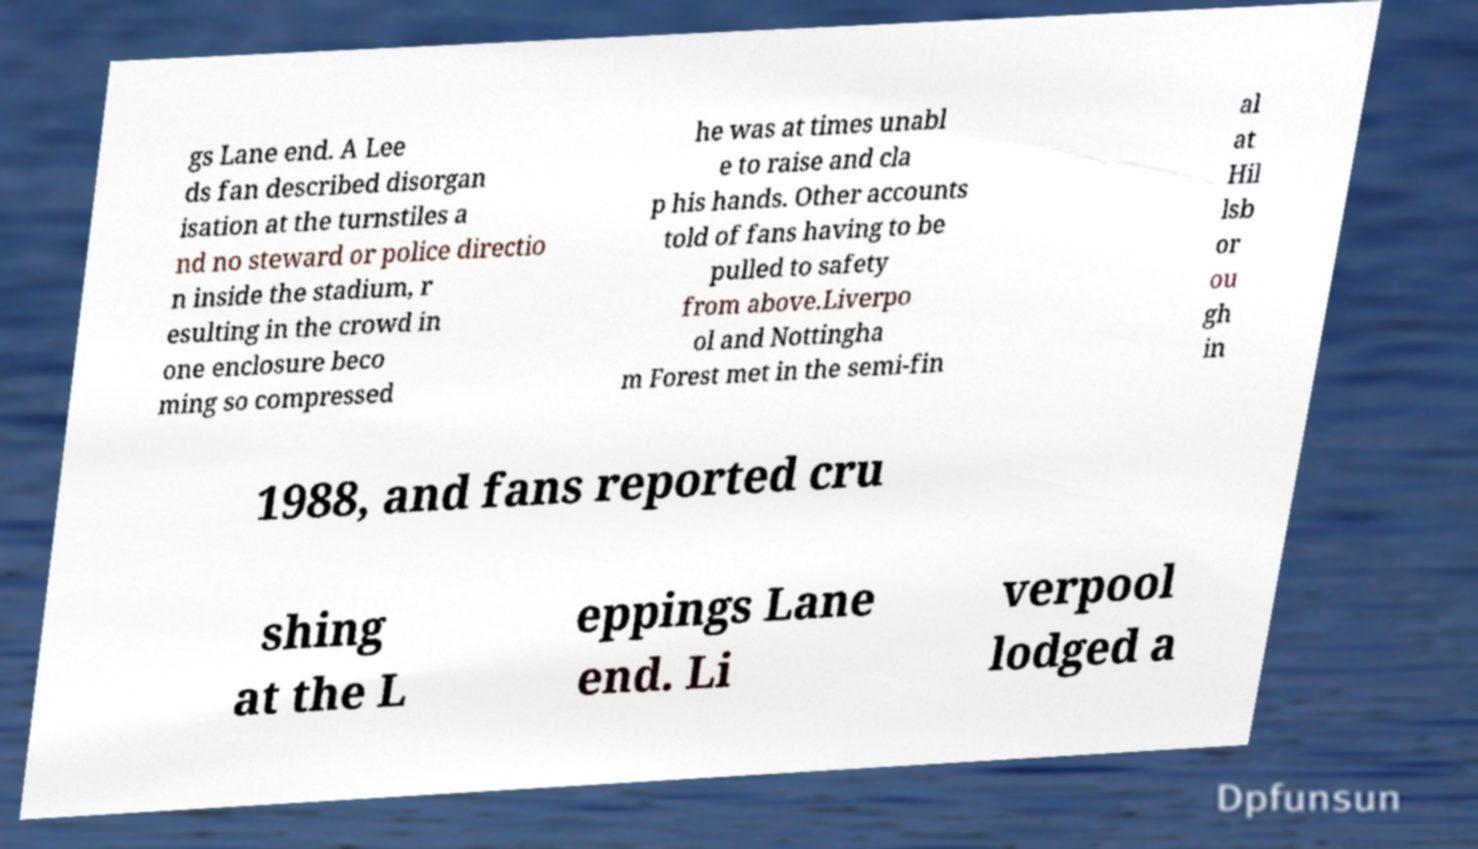Can you accurately transcribe the text from the provided image for me? gs Lane end. A Lee ds fan described disorgan isation at the turnstiles a nd no steward or police directio n inside the stadium, r esulting in the crowd in one enclosure beco ming so compressed he was at times unabl e to raise and cla p his hands. Other accounts told of fans having to be pulled to safety from above.Liverpo ol and Nottingha m Forest met in the semi-fin al at Hil lsb or ou gh in 1988, and fans reported cru shing at the L eppings Lane end. Li verpool lodged a 